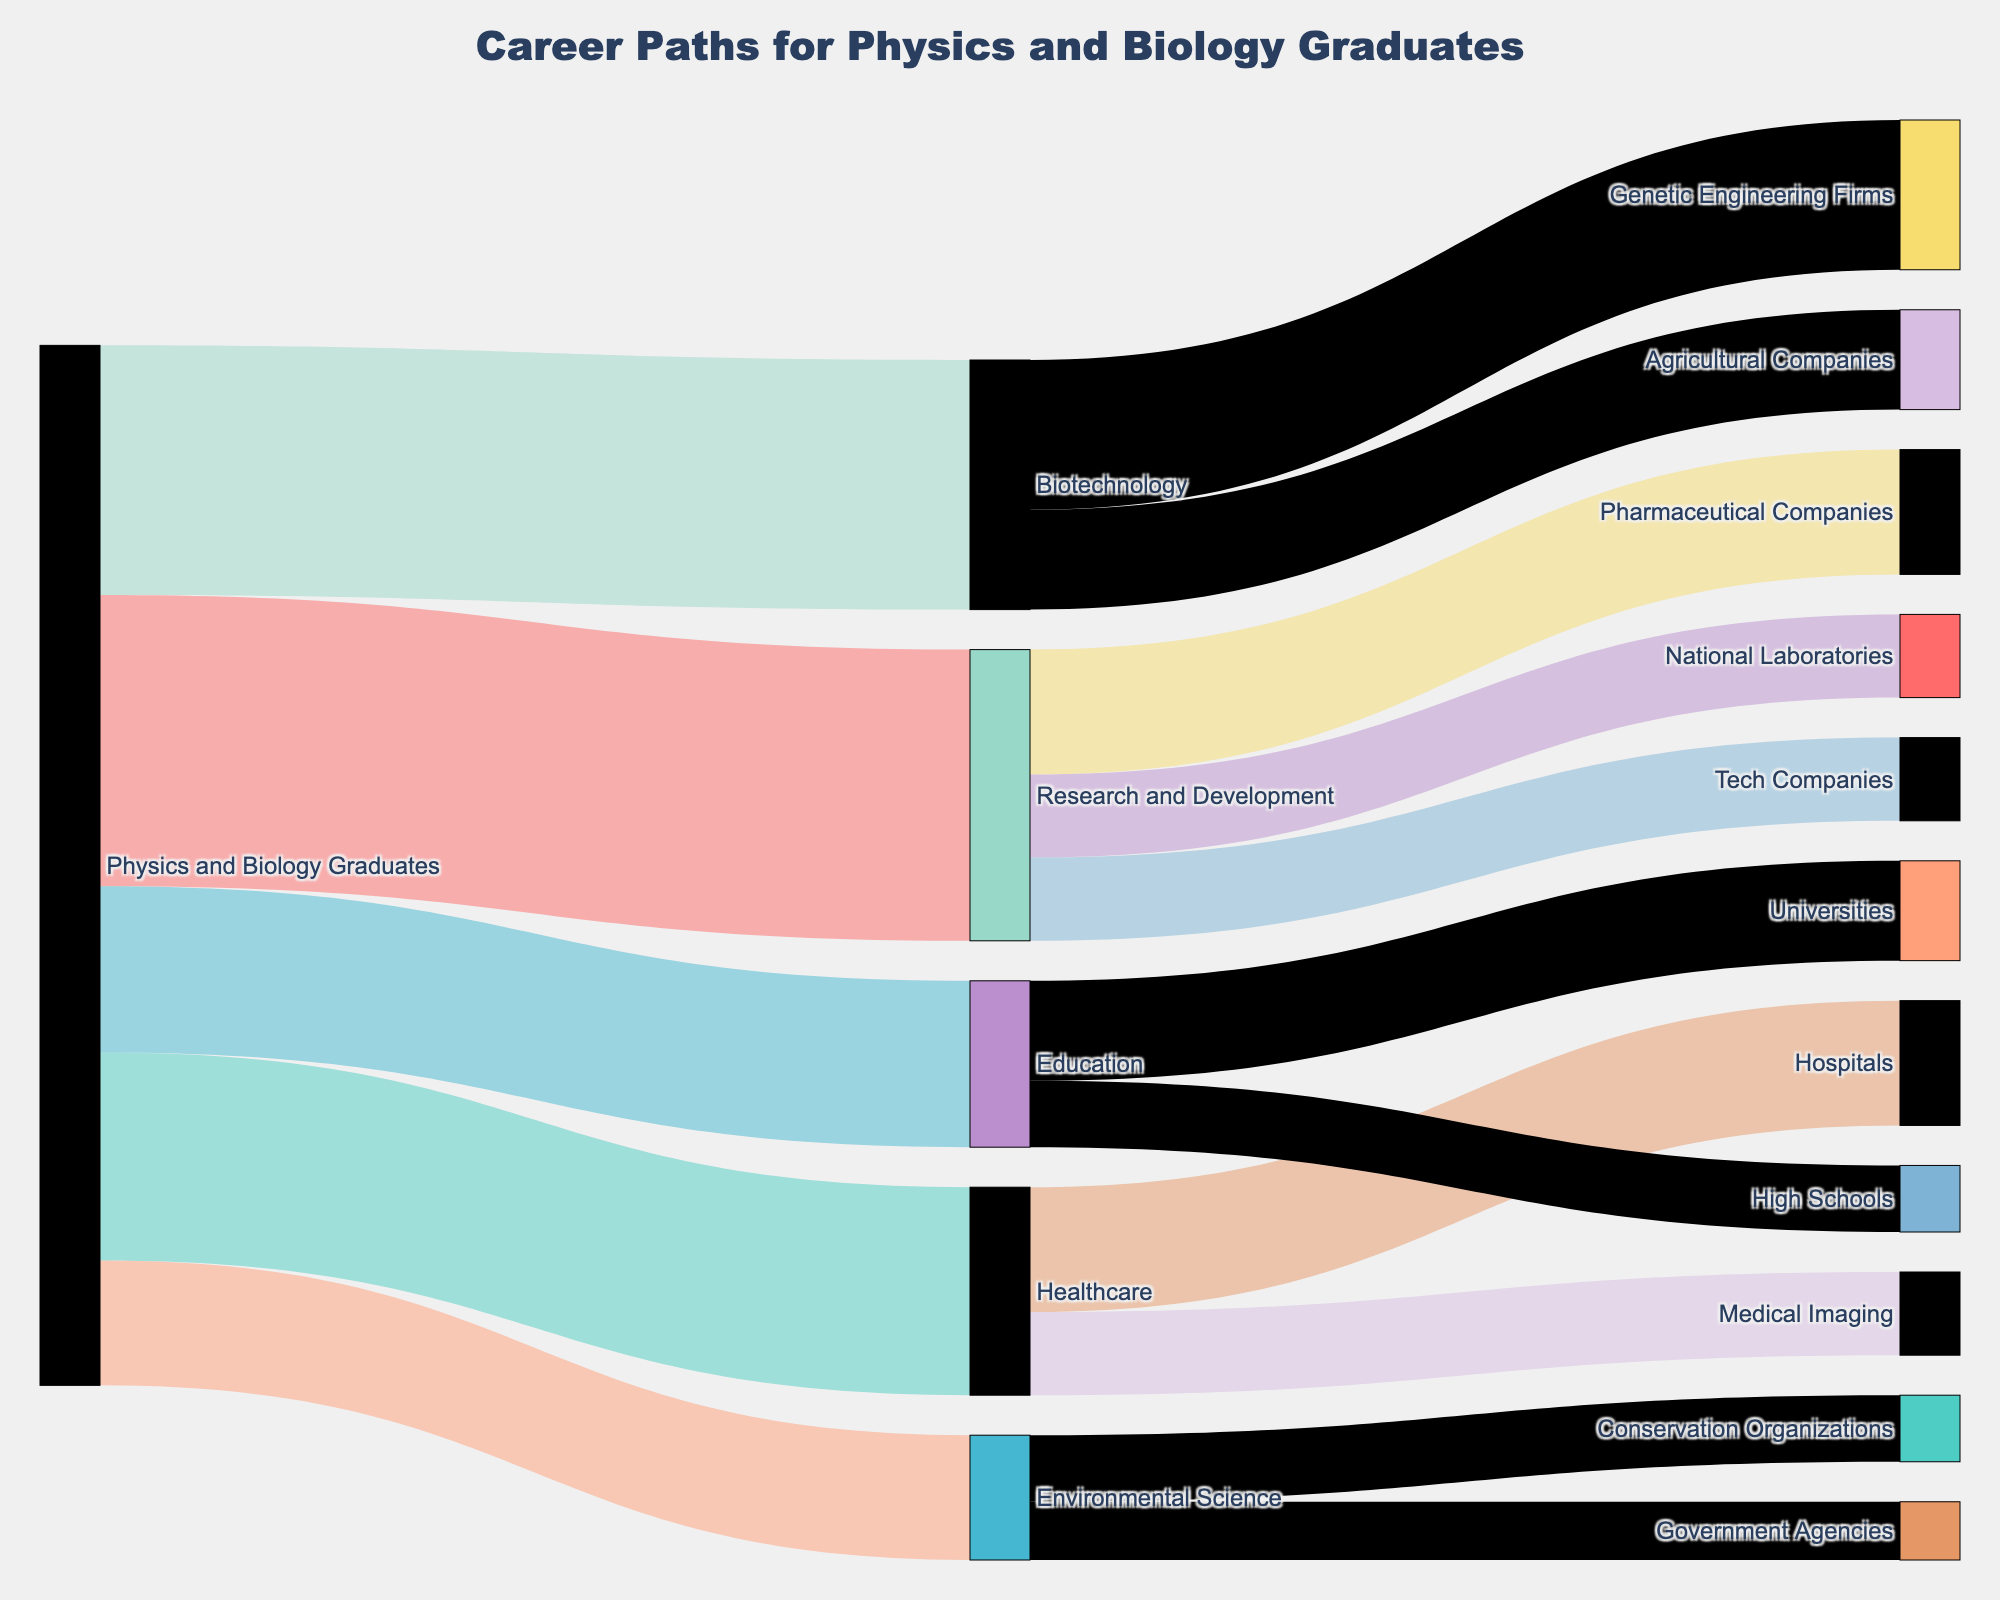What is the title of the figure? The title of the figure is displayed at the top of the Sankey diagram, summarizing the main topic of the diagram.
Answer: Career Paths for Physics and Biology Graduates Which career path has the highest number of graduates? By observing the width of the links between the source "Physics and Biology Graduates" and the various career paths, the link to "Research and Development" is the widest, indicating it has the highest number of graduates.
Answer: Research and Development How many graduates entered the Healthcare sector? The width of the link from "Physics and Biology Graduates" to "Healthcare" represents the number of graduates in that sector. The label on this link shows the value.
Answer: 25 What is the total number of graduates that entered either Research and Development or Biotechnology sectors? Add the values of graduates entering Research and Development and Biotechnology: 35 (Research and Development) + 30 (Biotechnology) = 65.
Answer: 65 Which sector received more graduates, Education or Environmental Science? Compare the values of graduates in Education and Environmental Science. Education has 20 graduates, while Environmental Science has 15 graduates.
Answer: Education How many graduates work in Pharmaceutical Companies from Research and Development? Look at the link from "Research and Development" to "Pharmaceutical Companies" to find the value indicated on this link.
Answer: 15 What is the sum of graduates working in Hospitals and Medical Imaging within the Healthcare sector? The values of graduates in Hospitals and Medical Imaging need to be summed: 15 (Hospitals) + 10 (Medical Imaging) = 25.
Answer: 25 Which specific career path within Biotechnology has more graduates, Genetic Engineering Firms or Agricultural Companies? Compare the values indicated on the links from Biotechnology to Genetic Engineering Firms and Agricultural Companies. Genetic Engineering Firms have 18 graduates, while Agricultural Companies have 12 graduates.
Answer: Genetic Engineering Firms How many graduates ended up working in Universities within the Education sector? Look at the link from Education to Universities and find the value indicated on this link.
Answer: 12 What is the breakdown of graduates in Environmental Science sector into specific organizations? The links from Environmental Science to Conservation Organizations and Government Agencies show their respective values. Conservation Organizations have 8 graduates and Government Agencies have 7 graduates.
Answer: Conservation Organizations: 8, Government Agencies: 7 